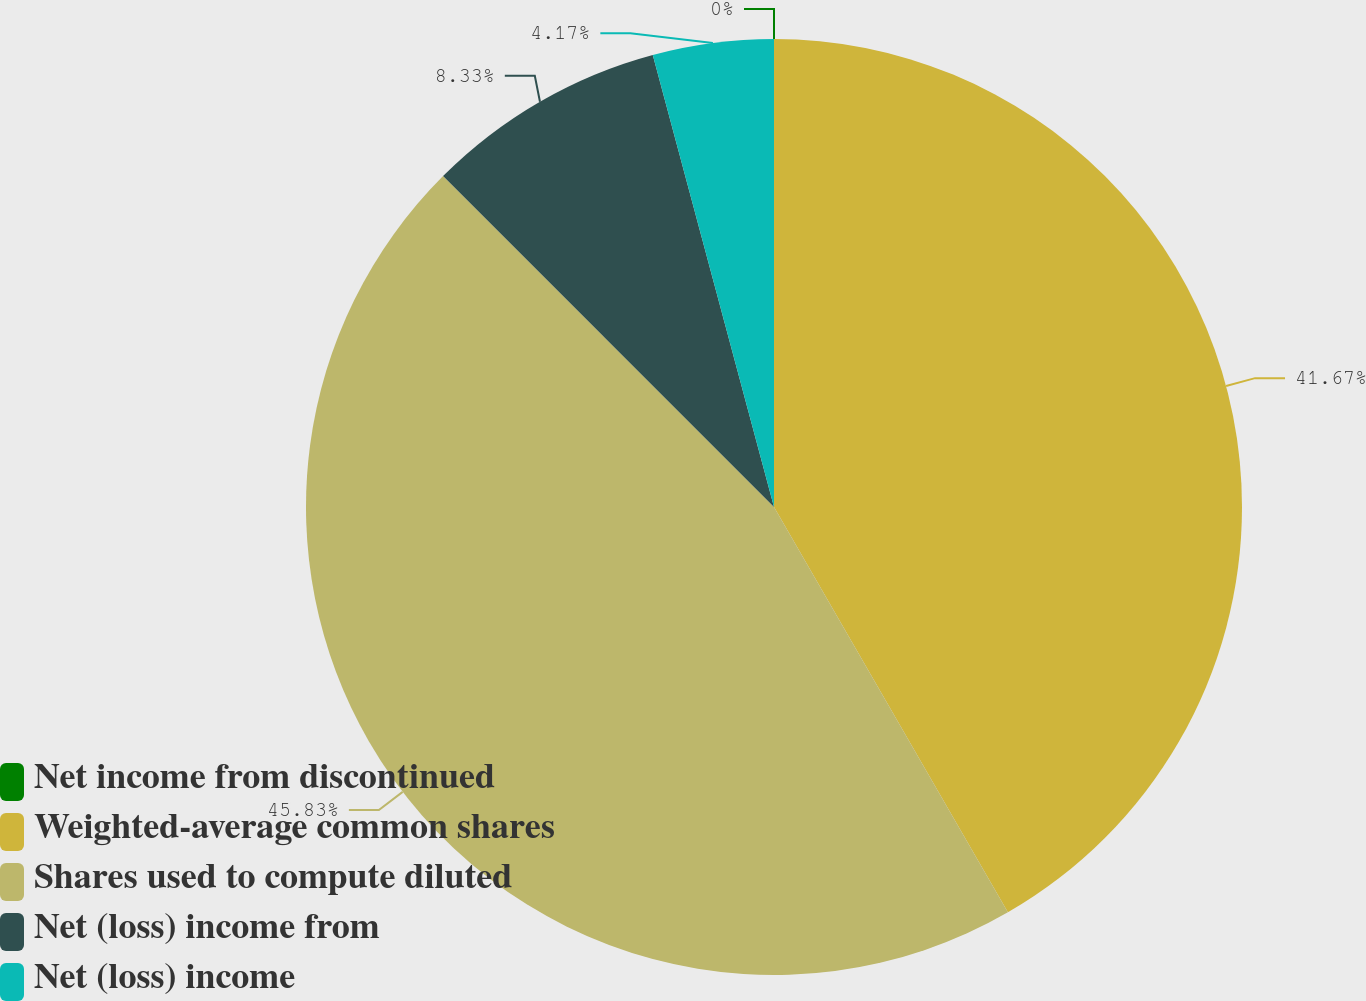Convert chart to OTSL. <chart><loc_0><loc_0><loc_500><loc_500><pie_chart><fcel>Net income from discontinued<fcel>Weighted-average common shares<fcel>Shares used to compute diluted<fcel>Net (loss) income from<fcel>Net (loss) income<nl><fcel>0.0%<fcel>41.67%<fcel>45.83%<fcel>8.33%<fcel>4.17%<nl></chart> 